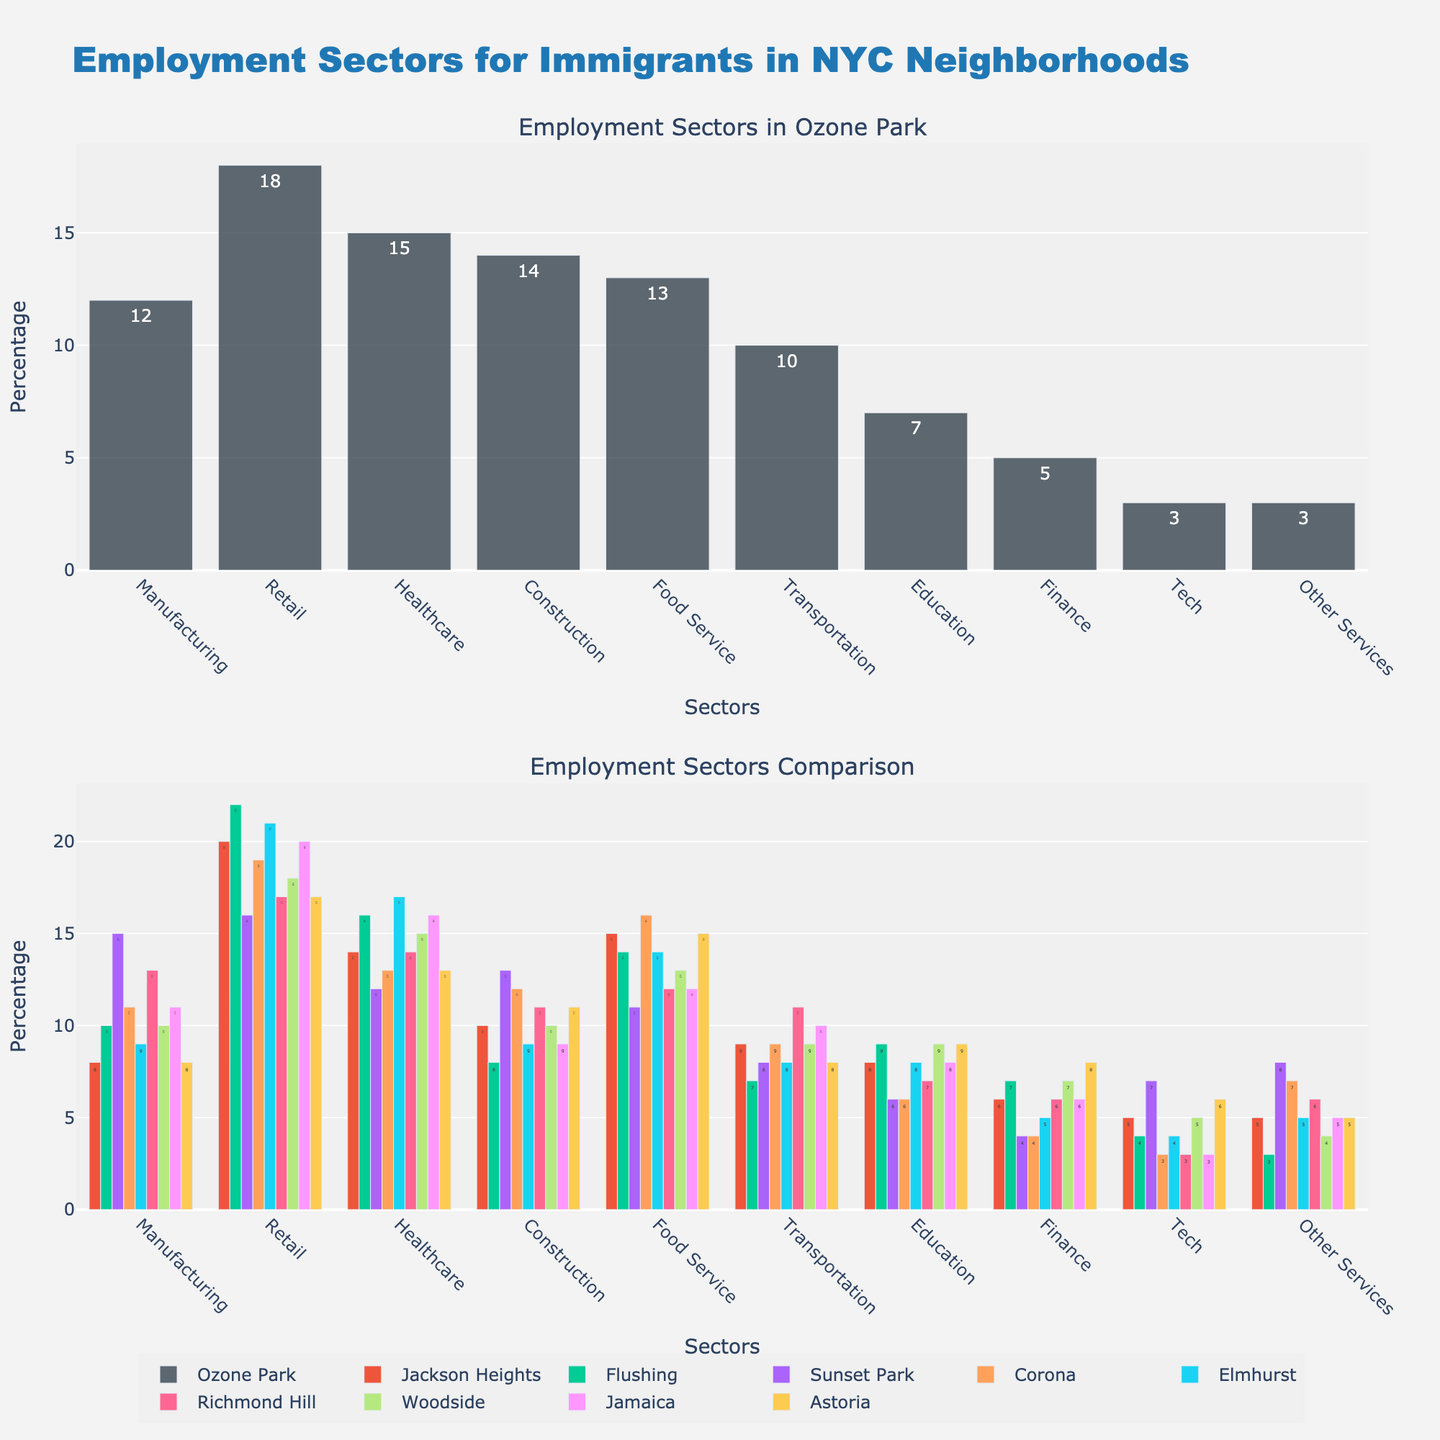How many more immigrants are employed in the Food Service sector in Elmhurst compared to Ozone Park? First, identify the percentage of immigrants employed in the Food Service sector in Elmhurst (14) and Ozone Park (13). Then, subtract the value for Ozone Park from Elmhurst (14 - 13). Hence, 1 more immigrant is employed in Elmhurst compared to Ozone Park in the Food Service sector.
Answer: 1 Which neighborhood has the highest percentage of immigrants employed in the Healthcare sector, and how does it compare to Ozone Park? Check the percentages for the Healthcare sector in all neighborhoods: Ozone Park (15), Jackson Heights (14), Flushing (16), Sunset Park (12), Corona (13), Elmhurst (17), Richmond Hill (14), Woodside (15), Jamaica (16), Astoria (13). Elmhurst has the highest percentage (17). Comparing to Ozone Park (15), Elmhurst is higher by 2.
Answer: Elmhurst, 2 higher Which neighborhood has the lowest percentage of immigrants employed in the Tech sector, and what is the value? Look at the percentages for the Tech sector across all neighborhoods: Ozone Park (3), Jackson Heights (5), Flushing (4), Sunset Park (7), Corona (3), Elmhurst (4), Richmond Hill (3), Woodside (5), Jamaica (3), Astoria (6). Ozone Park, Corona, Richmond Hill, and Jamaica share the lowest percentage (3).
Answer: Ozone Park, Corona, Richmond Hill, Jamaica, 3 What is the total percentage of immigrants employed in the Manufacturing, Construction, and Transportation sectors combined in Ozone Park? Sum the percentages for the Manufacturing (12), Construction (14), and Transportation (10) sectors in Ozone Park (12 + 14 + 10). The total is 36.
Answer: 36 Compare the percentage of immigrants employed in the Education sector in Ozone Park with Richmond Hill. Which neighborhood has a higher percentage and by how much? Check the values for Education in Ozone Park (7) and Richmond Hill (7). Since both have the same percentage, the difference is 0.
Answer: Both, 0 Which sector has the smallest variation in employment percentages across neighborhoods? Calculate the range (max - min) for each sector: Manufacturing (15-8=7), Retail (22-16=6), Healthcare (17-12=5), Construction (14-8=6), Food service (16-11=5), Transportation (11-7=4), Education (9-6=3), Finance (8-4=4), Tech (7-3=4), Other Services (8-3=5). The Education sector has the smallest variation of 3.
Answer: Education, 3 